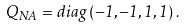Convert formula to latex. <formula><loc_0><loc_0><loc_500><loc_500>Q _ { N A } = d i a g \, ( - 1 , - 1 , 1 , 1 ) \, .</formula> 